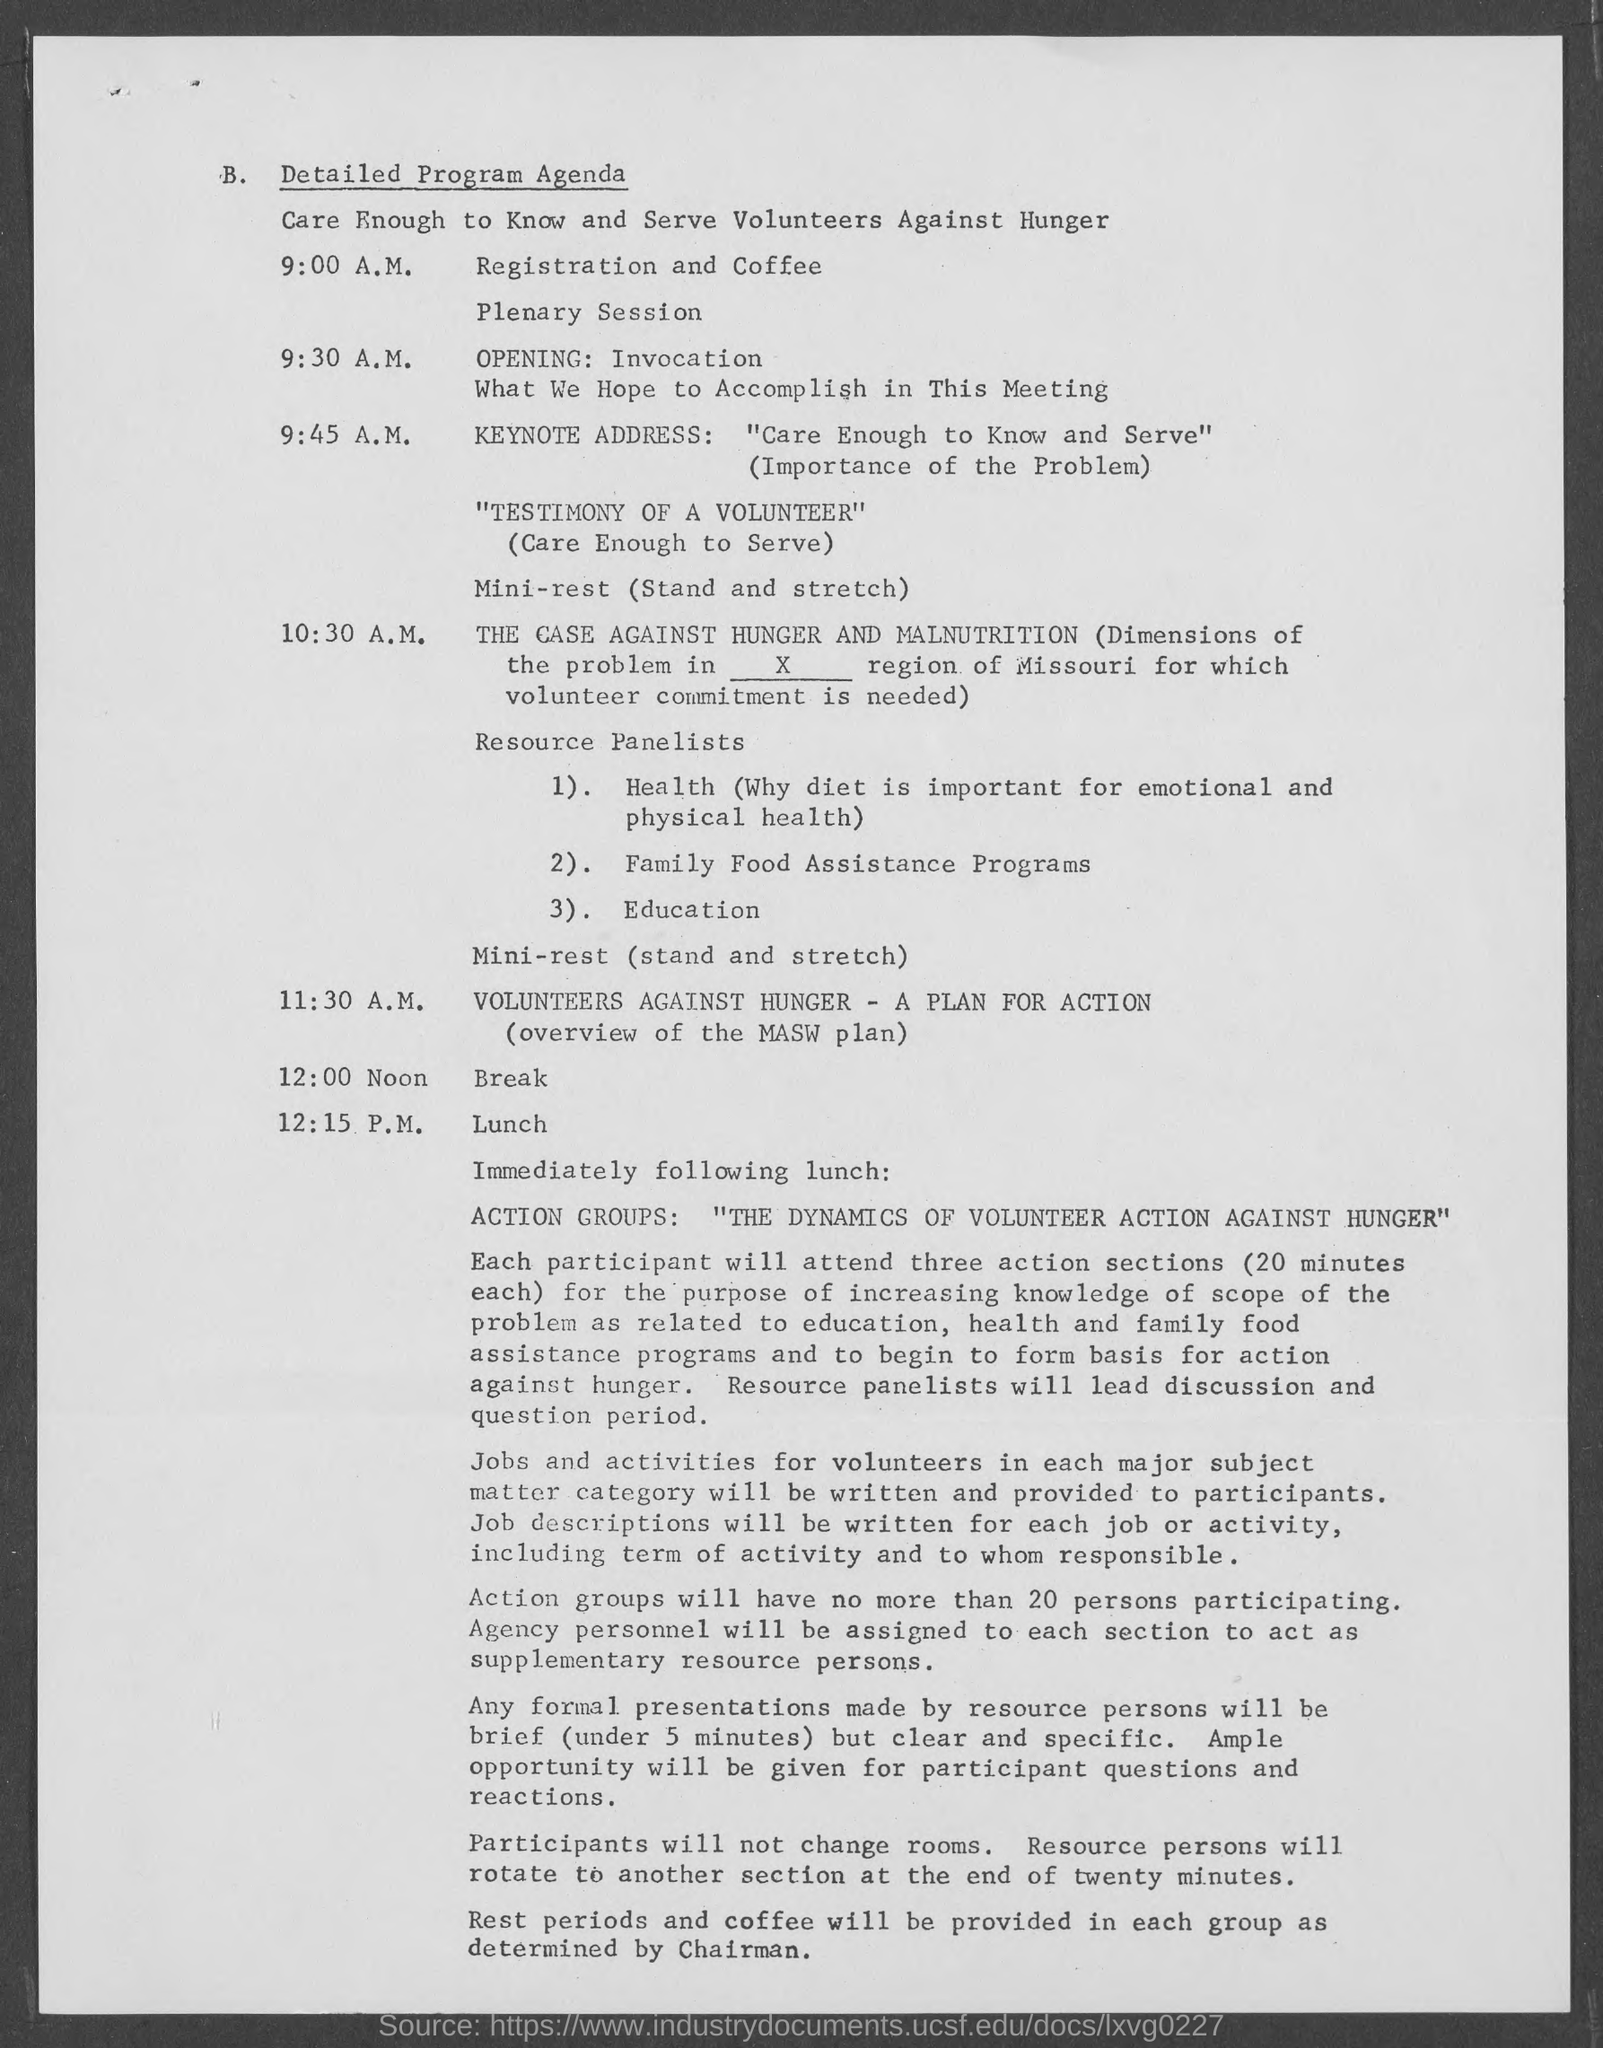What is under point B.?
Keep it short and to the point. Detailed Program Agenda. When is registration and coffee?
Ensure brevity in your answer.  9:00 A.M. What is the program at 10:30 A.M.?
Make the answer very short. The Case Against Hunger and Malnutrition. 